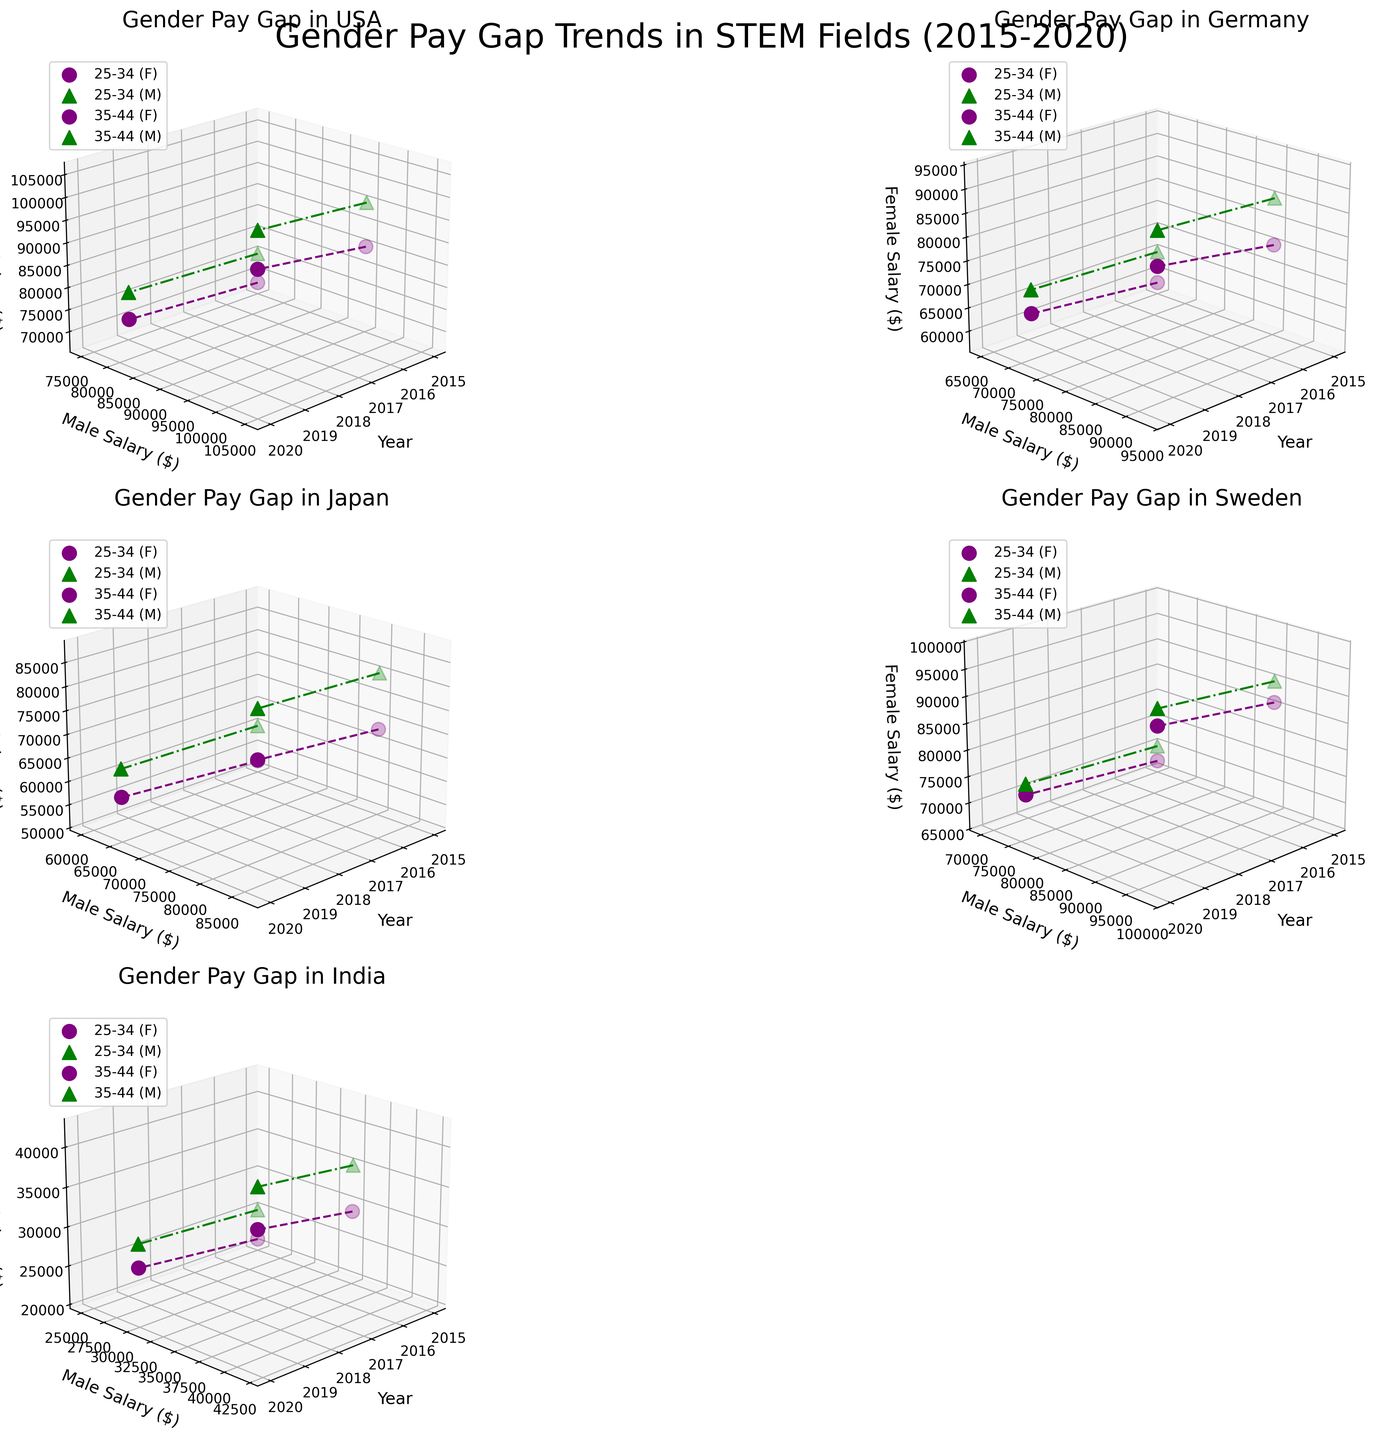What is the title of the figure? The title of a figure is typically found at the top and summarizes the overall content of the plot. In this case, the title is "Gender Pay Gap Trends in STEM Fields (2015-2020)" as specified in the code.
Answer: Gender Pay Gap Trends in STEM Fields (2015-2020) What age groups are included in the figure? Age groups are typically labeled in the legend or axis labels. This figure includes two age groups: "25-34" and "35-44".
Answer: 25-34 and 35-44 How does the gender pay gap in USA for the age group 25-34 change between 2015 and 2020? To determine the change, look for USA and age group 25-34 and compare male and female salaries from 2015 to 2020. For males, it increases from $75,000 to $82,000, and for females, it increases from $68,000 to $76,000. The gap narrows from $7,000 to $6,000.
Answer: It narrows from $7,000 to $6,000 Which country shows the least gender pay gap in the age group of 35-44 in 2020? Compare the salary differences between males and females for each country in the age group 35-44 in 2020. In Sweden, males earn $98,000 while females earn $95,000, resulting in the smallest gap of $3,000 compared to other countries.
Answer: Sweden What is the average salary for women in Germany across both age groups in 2015? To find the average, sum the salaries of women in Germany for both age groups in 2015 and divide by 2. The salaries are $58,000 (25-34) and $75,000 (35-44). Thus, (58000 + 75000)/2 = $66,500.
Answer: $66,500 How do female salaries in India in the age group 25-34 compare to 35-44 in 2020? For 2020, compare the female salaries in India for age groups 25-34 ($27,000) and 35-44 ($37,000). The salary for the age group 35-44 is higher by $10,000.
Answer: Higher by $10,000 Which country experienced the largest increase in female salary in the age group 25-34 from 2015 to 2020? Calculate the increase for each country in the age group 25-34 from 2015 to 2020. The increases are: USA ($76,000 - $68,000 = $8,000), Germany ($67,000 - $58,000 = $9,000), Japan ($59,000 - $52,000 = $7,000), Sweden ($74,000 - $67,000 = $7,000), and India ($27,000 - $21,000 = $6,000). Germany has the largest increase of $9,000.
Answer: Germany Is the male salary trend increasing or decreasing in Japan for the age group of 35-44 from 2015 to 2020? Review the male salary figures for Japan in age group 35-44 for 2015 ($80,000) and 2020 ($87,000). Since $87,000 is higher than $80,000, the trend is increasing.
Answer: Increasing Which country shows a decreasing trend in the gender pay gap for the age group 25-34 from 2015 to 2020? To identify the decreasing trend, check the gender pay gap for 2015 and 2020 by subtracting the female salary from the male salary for the age group 25-34. Sweden shows a decrease from $3,000 in 2015 to $2,000 in 2020.
Answer: Sweden 